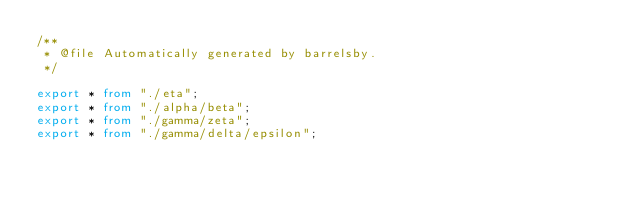<code> <loc_0><loc_0><loc_500><loc_500><_TypeScript_>/**
 * @file Automatically generated by barrelsby.
 */

export * from "./eta";
export * from "./alpha/beta";
export * from "./gamma/zeta";
export * from "./gamma/delta/epsilon";
</code> 